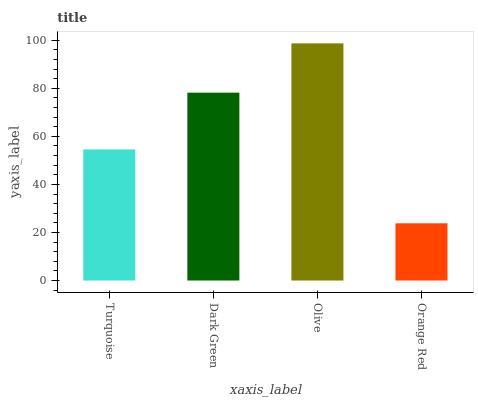Is Orange Red the minimum?
Answer yes or no. Yes. Is Olive the maximum?
Answer yes or no. Yes. Is Dark Green the minimum?
Answer yes or no. No. Is Dark Green the maximum?
Answer yes or no. No. Is Dark Green greater than Turquoise?
Answer yes or no. Yes. Is Turquoise less than Dark Green?
Answer yes or no. Yes. Is Turquoise greater than Dark Green?
Answer yes or no. No. Is Dark Green less than Turquoise?
Answer yes or no. No. Is Dark Green the high median?
Answer yes or no. Yes. Is Turquoise the low median?
Answer yes or no. Yes. Is Orange Red the high median?
Answer yes or no. No. Is Orange Red the low median?
Answer yes or no. No. 